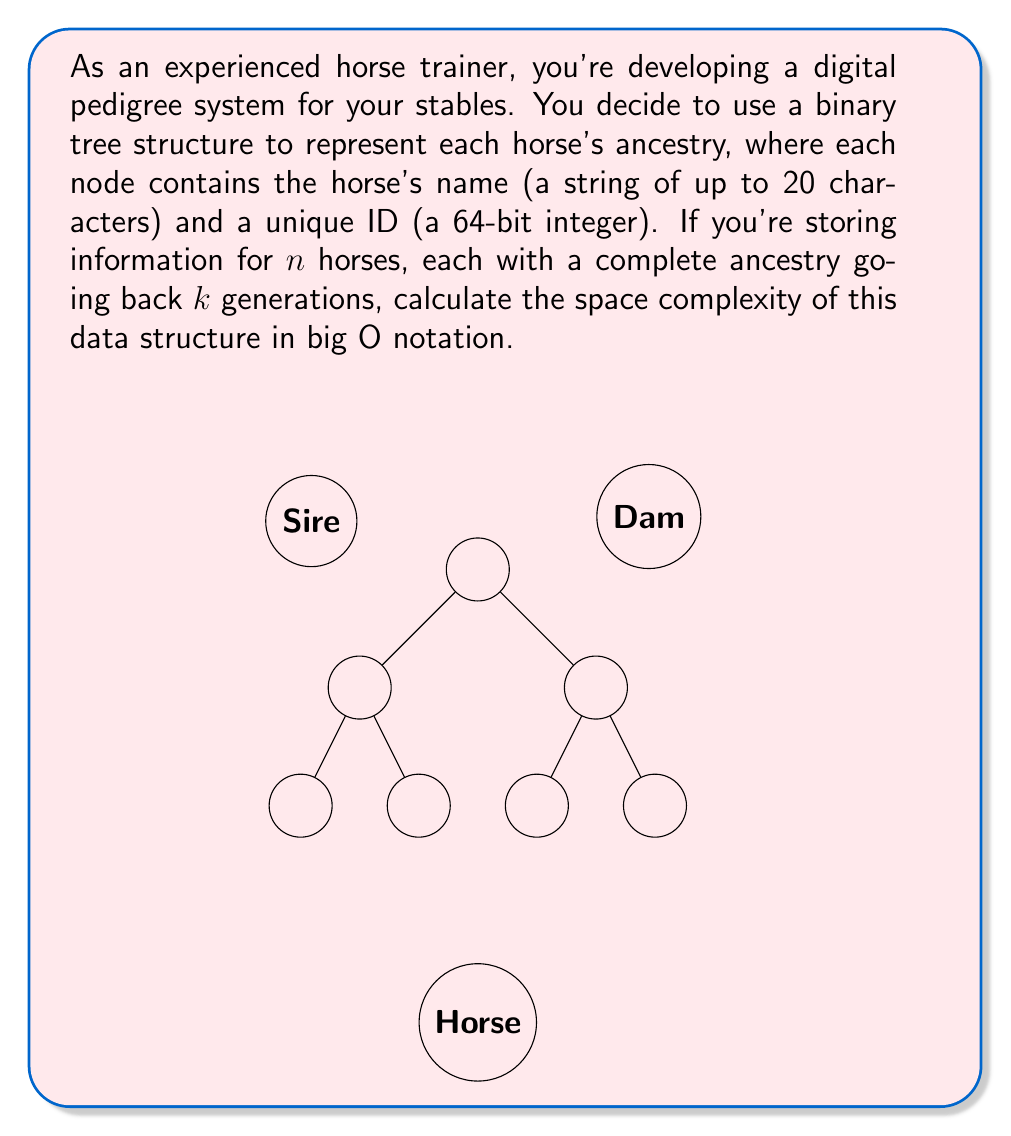Provide a solution to this math problem. Let's approach this step-by-step:

1) First, let's calculate the space required for each node in the binary tree:
   - Name: 20 characters * 1 byte per character = 20 bytes
   - ID: 64-bit integer = 8 bytes
   Total per node: 28 bytes

2) Now, let's consider the number of nodes in each tree:
   - In a complete binary tree with $k$ generations, the number of nodes is $2^{k+1} - 1$
   - This is because we have $1 + 2 + 4 + ... + 2^k = 2^{k+1} - 1$ nodes

3) For $n$ horses, we have $n$ such trees

4) Therefore, the total number of nodes is:
   $n * (2^{k+1} - 1)$

5) The total space required is:
   $28 * n * (2^{k+1} - 1)$ bytes

6) In big O notation, we ignore constant factors and lower order terms. $2^{k+1} - 1$ simplifies to $O(2^k)$

7) Therefore, the space complexity is $O(n * 2^k)$

This makes sense intuitively: the space grows linearly with the number of horses, and exponentially with the number of generations tracked.
Answer: $O(n * 2^k)$ 